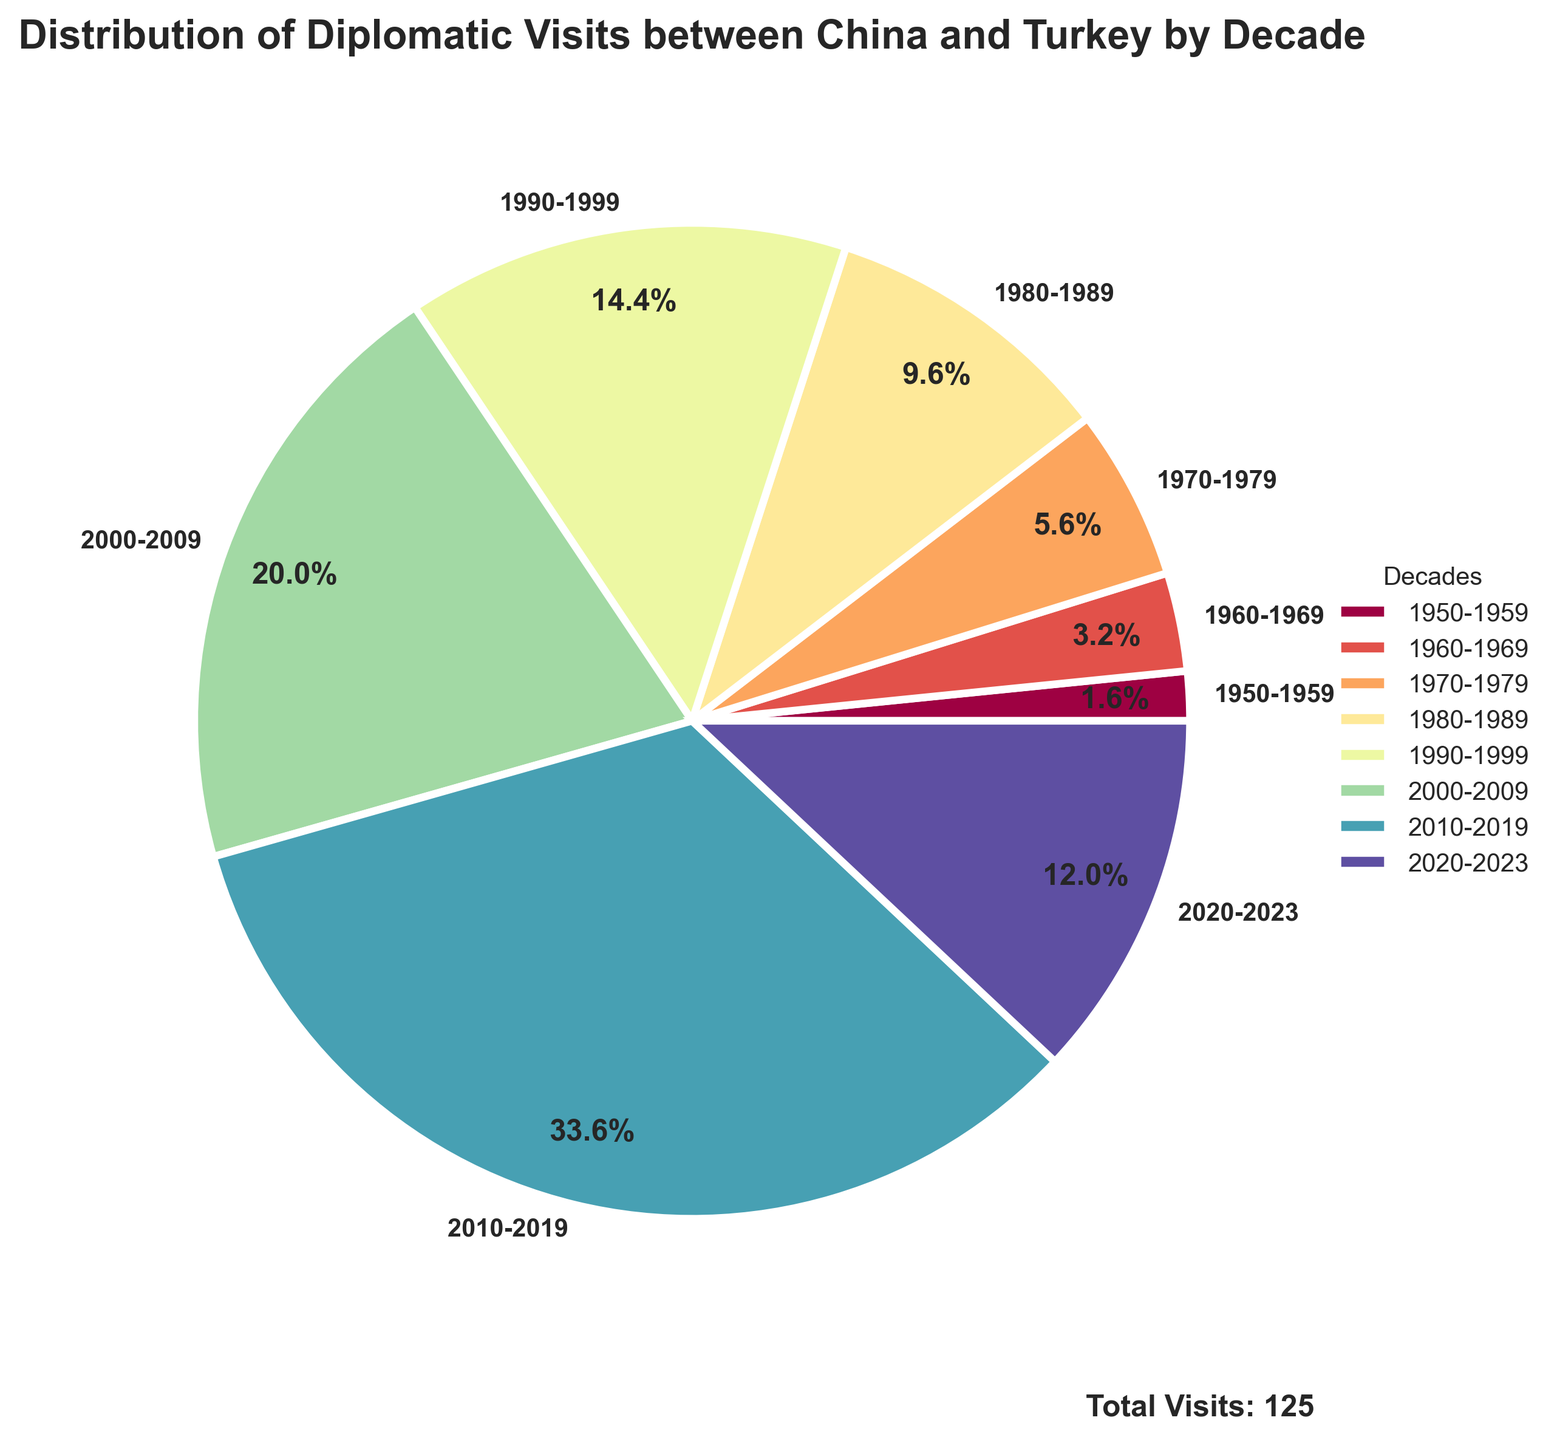What decade had the highest number of diplomatic visits? From the pie chart, the 2010-2019 decade shows the highest percentage, indicating the most significant number of visits compared to other decades.
Answer: 2010-2019 What is the percentage of diplomatic visits that occurred between 2000-2009? The labeled pie slice for 2000-2009 shows the percentage directly, which can be read off the chart.
Answer: 21.2% What is the total number of diplomatic visits represented in the pie chart? The chart includes an annotation that states the total number of visits; by summing up visits for each decade: 2+4+7+12+18+25+42+15 = 125.
Answer: 125 Which decades have more visits, before or after 2000? Sum the visits before 2000 (2+4+7+12+18 = 43) and after 2000 (25+42+15 = 82) and compare.
Answer: After 2000 What is the difference in the number of visits between the 2010-2019 and 2000-2009 decades? Subtract the number of visits in the 2000-2009 decade (25) from the 2010-2019 decade (42). 42 - 25 = 17.
Answer: 17 How many more visits were there in the decade of 2020-2023 compared to the decade of 1950-1959? Subtract the number of visits in the decade of 1950-1959 (2) from the 2020-2023 (15). 15 - 2 = 13.
Answer: 13 What fraction of the total visits happen in the 2010-2019 decade? Divide the number of visits in the 2010-2019 decade (42) by the total number of visits (125). 42 / 125 = 0.336, or approximately 33.6%.
Answer: 33.6% Which decade had twice the number of visits as the 1970-1979 decade? The 1970-1979 decade had 7 visits. Look for a decade with approximately 2*7 = 14 visits. The 1980-1989 decade had 12 visits, which is close but not exact. Upon further inspection, no decade has exactly double the visits of 1970-1979.
Answer: None What's the average number of visits per decade? Sum the visits and divide by the number of decades (8): (2+4+7+12+18+25+42+15) / 8 = 125 / 8 = 15.625.
Answer: 15.625 